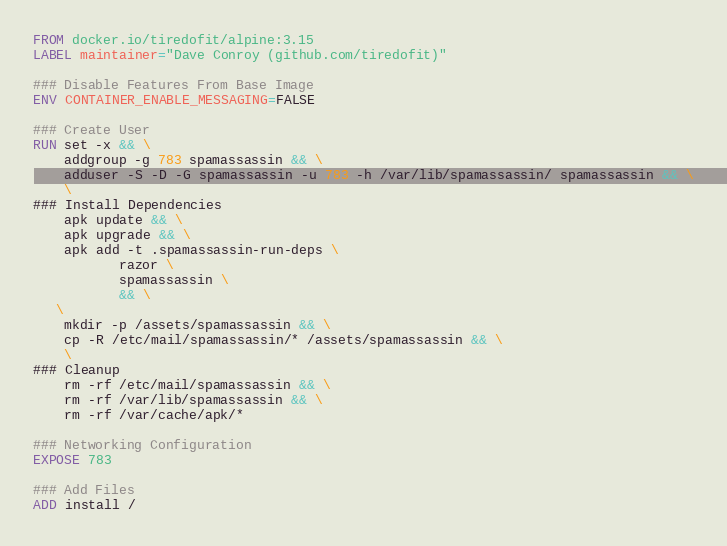Convert code to text. <code><loc_0><loc_0><loc_500><loc_500><_Dockerfile_>FROM docker.io/tiredofit/alpine:3.15
LABEL maintainer="Dave Conroy (github.com/tiredofit)"

### Disable Features From Base Image
ENV CONTAINER_ENABLE_MESSAGING=FALSE

### Create User
RUN set -x && \
    addgroup -g 783 spamassassin && \
    adduser -S -D -G spamassassin -u 783 -h /var/lib/spamassassin/ spamassassin && \
    \
### Install Dependencies
    apk update && \
    apk upgrade && \
    apk add -t .spamassassin-run-deps \
           razor \
           spamassassin \
           && \
   \
    mkdir -p /assets/spamassassin && \
    cp -R /etc/mail/spamassassin/* /assets/spamassassin && \
    \
### Cleanup
    rm -rf /etc/mail/spamassassin && \
    rm -rf /var/lib/spamassassin && \
    rm -rf /var/cache/apk/*

### Networking Configuration
EXPOSE 783

### Add Files
ADD install /
</code> 